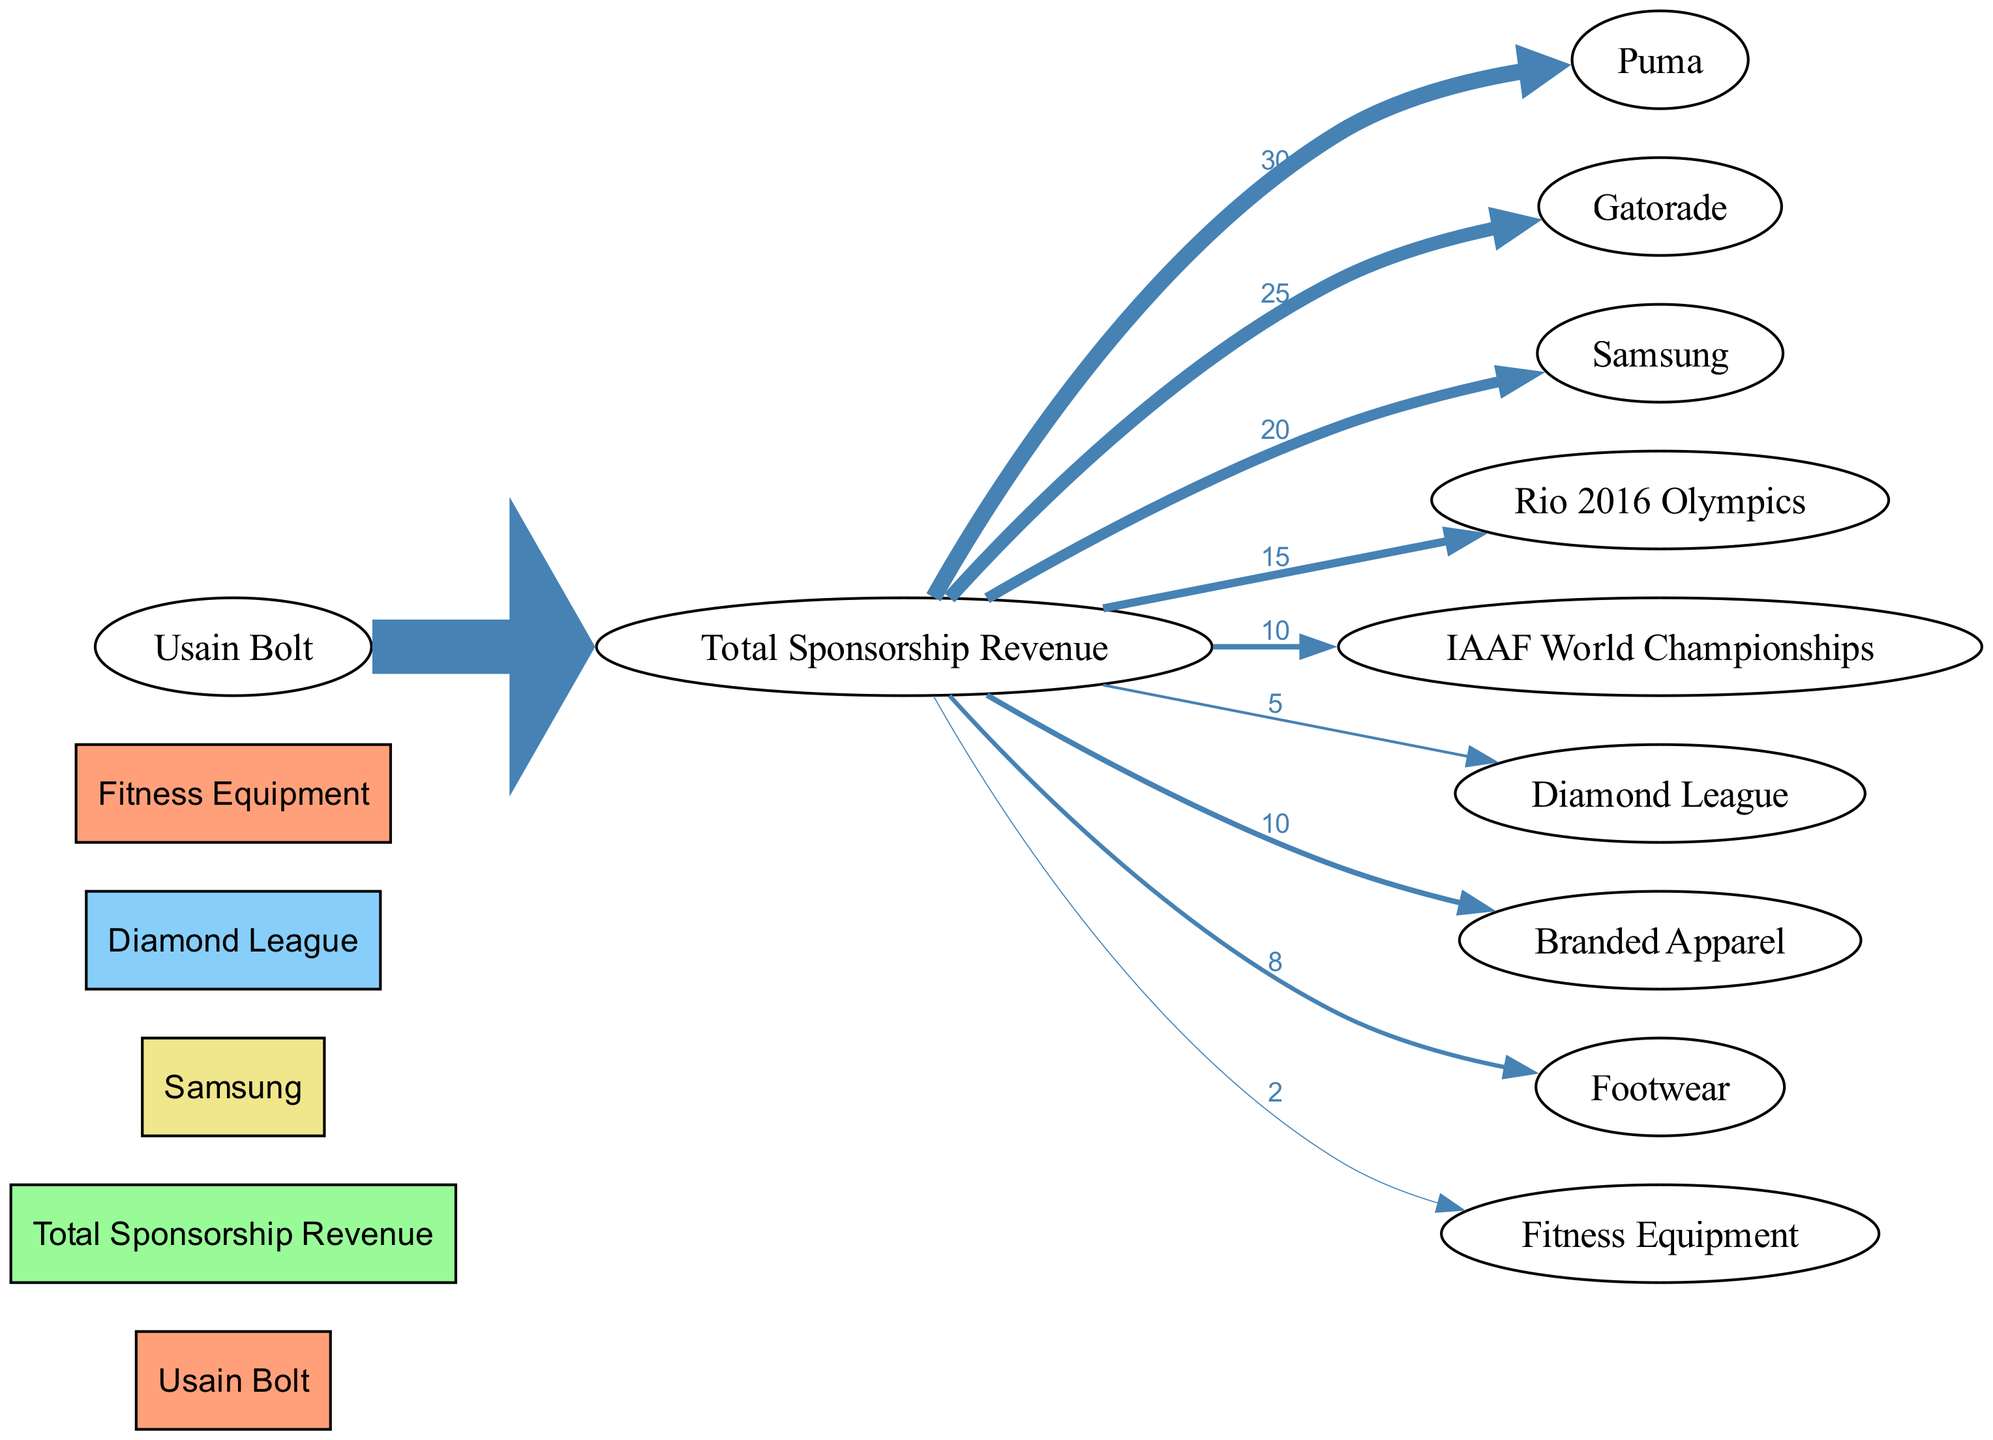What is the total sponsorship revenue allocated to Puma? To find the sponsorship revenue allocated to Puma, I need to look at the link connecting "Total Sponsorship Revenue" to "Puma." The value indicated on that link is 30.
Answer: 30 How many endorsement deals are represented in the diagram? The diagram includes nodes specifically labeled as "Endorsement Deals." There are three such nodes: Puma, Gatorade, and Samsung. Therefore, I count these nodes to determine the total number of endorsement deals.
Answer: 3 What percentage of total sponsorship revenue is allocated to Gatorade? The total sponsorship revenue is 100. The revenue allocated to Gatorade is 25. I calculate the percentage by (25/100) * 100, which equals 25%.
Answer: 25% What is the least amount of revenue assigned to an event sponsorship? I check the links connecting "Total Sponsorship Revenue" to each event sponsorship: Rio 2016 Olympics has 15, IAAF World Championships has 10, and Diamond League has 5. The smallest value is 5, which is assigned to Diamond League.
Answer: 5 Which category receives the highest funds from total sponsorship revenue? I need to review all the links connected to "Total Sponsorship Revenue" to compare the values. Upon examination, Puma has the highest allocation at 30, compared to Gatorade (25) and others. Therefore, Puma is the category receiving the highest funds.
Answer: Puma How much revenue is allocated to fitness equipment as merchandise sales? To get the revenue allocated to fitness equipment, I locate the link from "Total Sponsorship Revenue" to "Fitness Equipment." The value indicated on that link is 2.
Answer: 2 What is the total amount allocated to event sponsorships combined? To find the total for event sponsorships, I sum up each of the values assigned to the event nodes: Rio 2016 Olympics (15), IAAF World Championships (10), and Diamond League (5). Thus, 15 + 10 + 5 equals a total of 30.
Answer: 30 How many nodes represent sponsorship through merchandise sales? The diagram includes nodes for "Merchandise Sales," which are Branded Apparel, Footwear, and Fitness Equipment. I count these nodes to find the total number of merchandise sales categories represented.
Answer: 3 